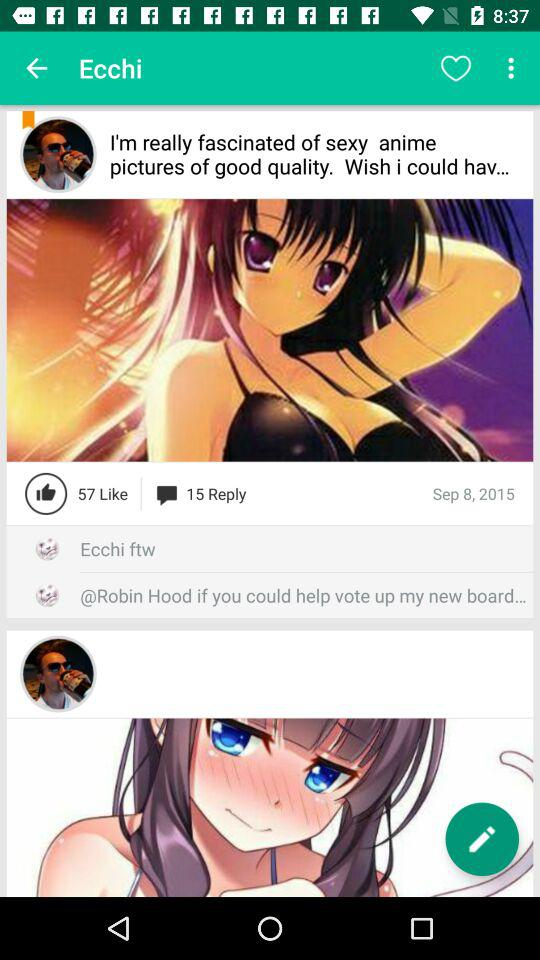What is the date on which anime pictures are posted? The date is September 8, 2015. 